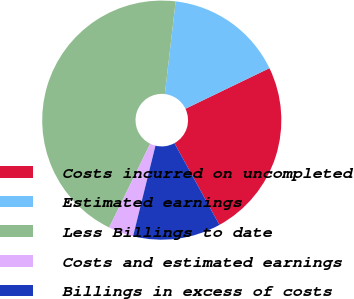Convert chart to OTSL. <chart><loc_0><loc_0><loc_500><loc_500><pie_chart><fcel>Costs incurred on uncompleted<fcel>Estimated earnings<fcel>Less Billings to date<fcel>Costs and estimated earnings<fcel>Billings in excess of costs<nl><fcel>24.15%<fcel>15.99%<fcel>44.61%<fcel>3.39%<fcel>11.87%<nl></chart> 